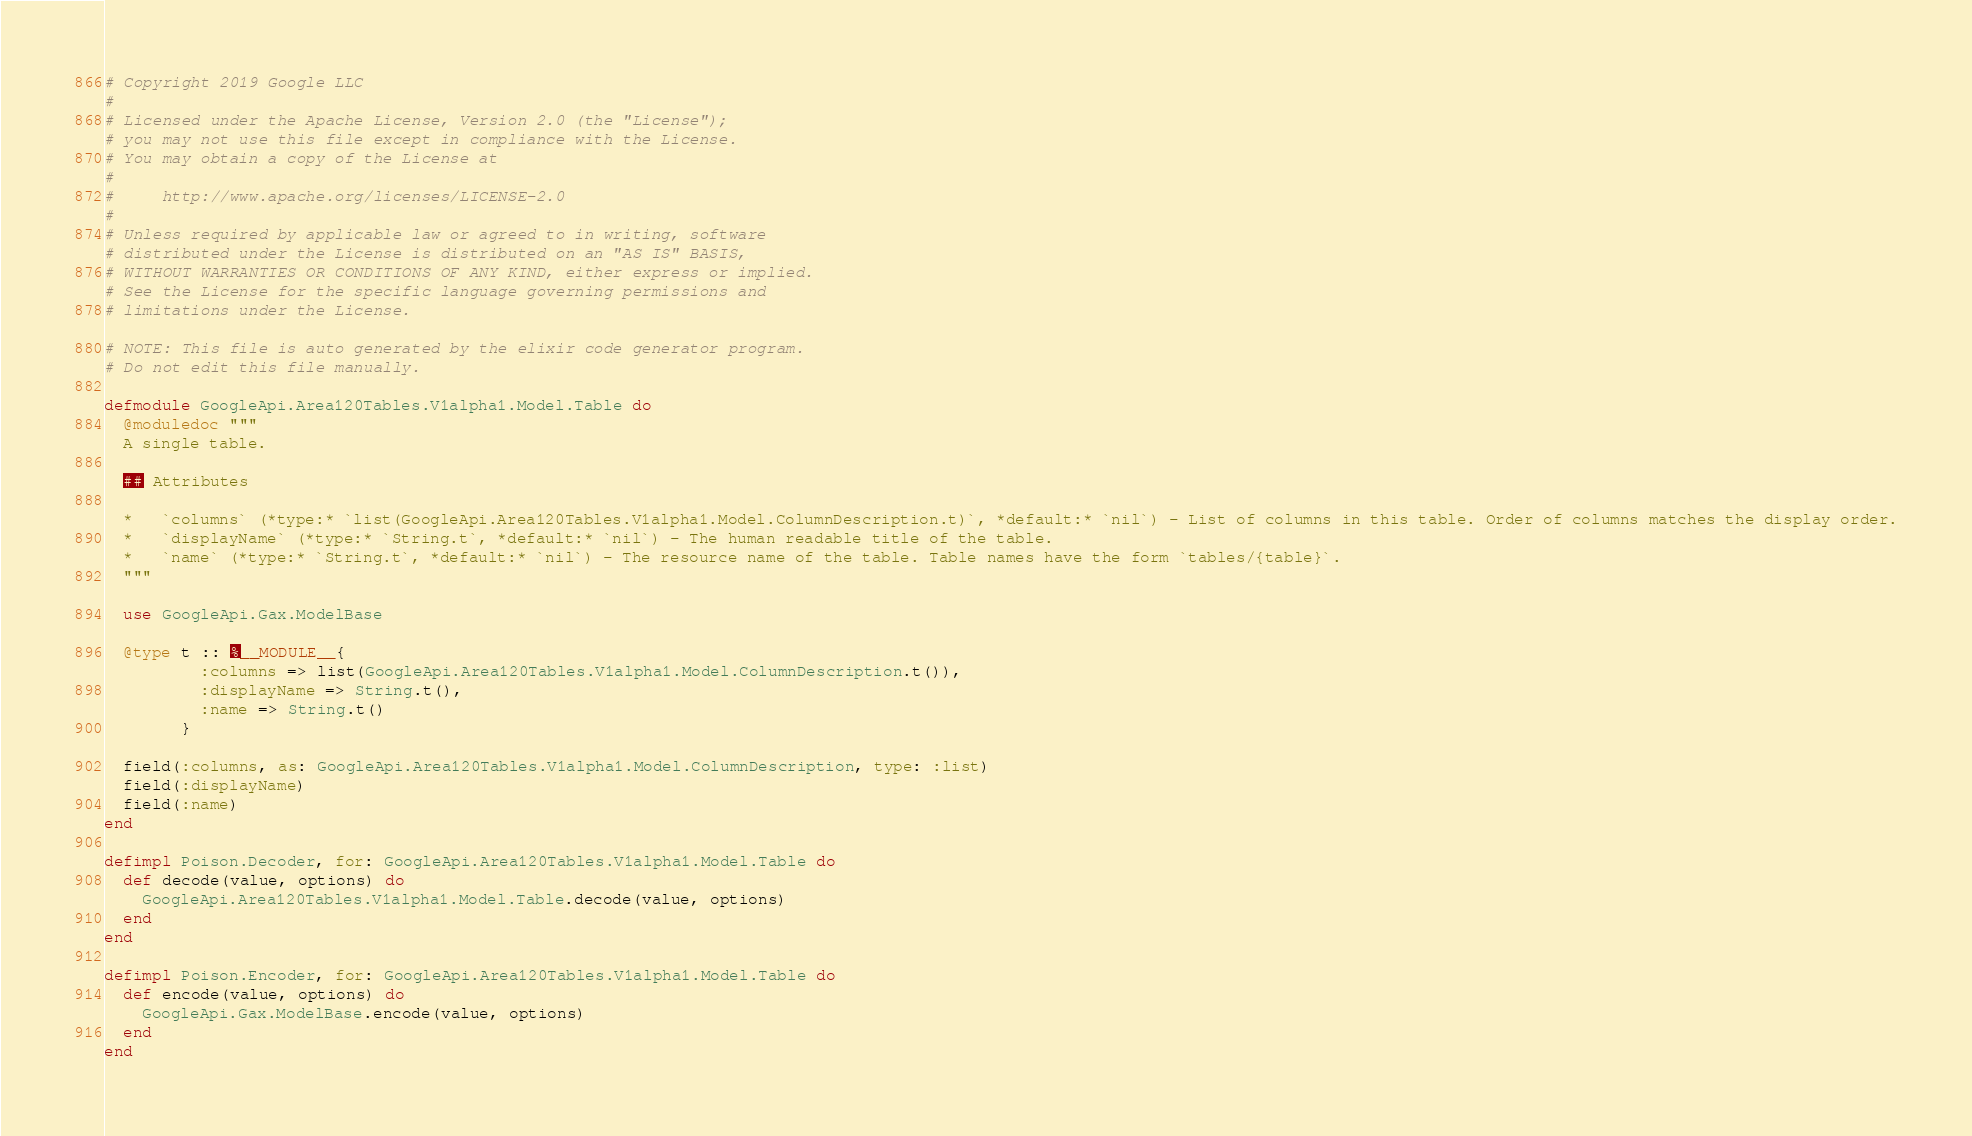Convert code to text. <code><loc_0><loc_0><loc_500><loc_500><_Elixir_># Copyright 2019 Google LLC
#
# Licensed under the Apache License, Version 2.0 (the "License");
# you may not use this file except in compliance with the License.
# You may obtain a copy of the License at
#
#     http://www.apache.org/licenses/LICENSE-2.0
#
# Unless required by applicable law or agreed to in writing, software
# distributed under the License is distributed on an "AS IS" BASIS,
# WITHOUT WARRANTIES OR CONDITIONS OF ANY KIND, either express or implied.
# See the License for the specific language governing permissions and
# limitations under the License.

# NOTE: This file is auto generated by the elixir code generator program.
# Do not edit this file manually.

defmodule GoogleApi.Area120Tables.V1alpha1.Model.Table do
  @moduledoc """
  A single table.

  ## Attributes

  *   `columns` (*type:* `list(GoogleApi.Area120Tables.V1alpha1.Model.ColumnDescription.t)`, *default:* `nil`) - List of columns in this table. Order of columns matches the display order.
  *   `displayName` (*type:* `String.t`, *default:* `nil`) - The human readable title of the table.
  *   `name` (*type:* `String.t`, *default:* `nil`) - The resource name of the table. Table names have the form `tables/{table}`.
  """

  use GoogleApi.Gax.ModelBase

  @type t :: %__MODULE__{
          :columns => list(GoogleApi.Area120Tables.V1alpha1.Model.ColumnDescription.t()),
          :displayName => String.t(),
          :name => String.t()
        }

  field(:columns, as: GoogleApi.Area120Tables.V1alpha1.Model.ColumnDescription, type: :list)
  field(:displayName)
  field(:name)
end

defimpl Poison.Decoder, for: GoogleApi.Area120Tables.V1alpha1.Model.Table do
  def decode(value, options) do
    GoogleApi.Area120Tables.V1alpha1.Model.Table.decode(value, options)
  end
end

defimpl Poison.Encoder, for: GoogleApi.Area120Tables.V1alpha1.Model.Table do
  def encode(value, options) do
    GoogleApi.Gax.ModelBase.encode(value, options)
  end
end
</code> 